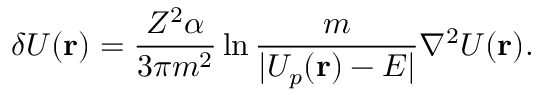<formula> <loc_0><loc_0><loc_500><loc_500>\delta U ( { r } ) = \frac { Z ^ { 2 } \alpha } { 3 \pi m ^ { 2 } } \ln \frac { m } { | U _ { p } ( { r } ) - E | } \nabla ^ { 2 } U ( { r } ) .</formula> 